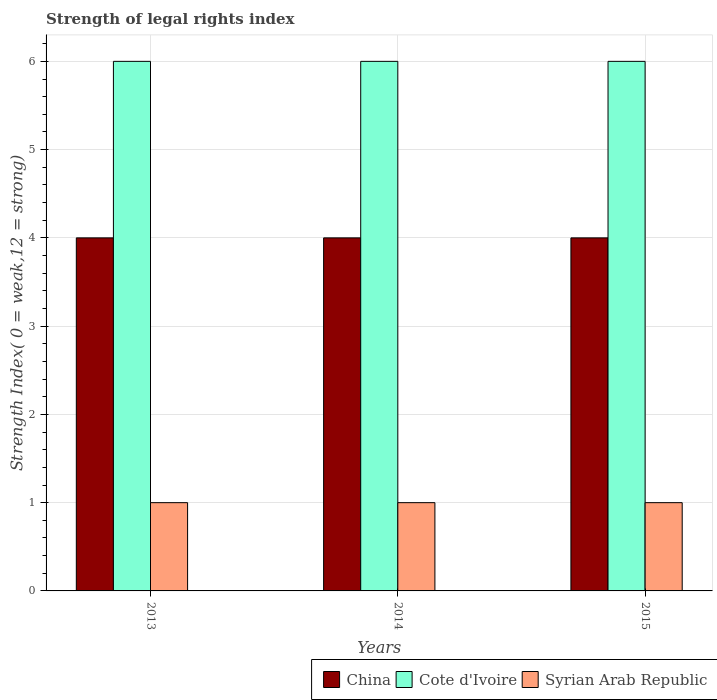How many groups of bars are there?
Your answer should be very brief. 3. Are the number of bars per tick equal to the number of legend labels?
Give a very brief answer. Yes. Are the number of bars on each tick of the X-axis equal?
Make the answer very short. Yes. How many bars are there on the 3rd tick from the right?
Your answer should be very brief. 3. What is the strength index in Syrian Arab Republic in 2014?
Provide a short and direct response. 1. Across all years, what is the maximum strength index in Cote d'Ivoire?
Your answer should be compact. 6. Across all years, what is the minimum strength index in China?
Your answer should be very brief. 4. In which year was the strength index in Syrian Arab Republic minimum?
Your answer should be very brief. 2013. What is the total strength index in Syrian Arab Republic in the graph?
Make the answer very short. 3. What is the difference between the strength index in Cote d'Ivoire in 2015 and the strength index in Syrian Arab Republic in 2013?
Give a very brief answer. 5. In the year 2013, what is the difference between the strength index in China and strength index in Syrian Arab Republic?
Make the answer very short. 3. In how many years, is the strength index in Cote d'Ivoire greater than 2?
Provide a short and direct response. 3. What is the ratio of the strength index in China in 2013 to that in 2014?
Your response must be concise. 1. Is the difference between the strength index in China in 2014 and 2015 greater than the difference between the strength index in Syrian Arab Republic in 2014 and 2015?
Your response must be concise. No. What is the difference between the highest and the second highest strength index in Cote d'Ivoire?
Provide a succinct answer. 0. In how many years, is the strength index in Cote d'Ivoire greater than the average strength index in Cote d'Ivoire taken over all years?
Offer a terse response. 0. What does the 2nd bar from the left in 2013 represents?
Offer a terse response. Cote d'Ivoire. What does the 2nd bar from the right in 2013 represents?
Your answer should be compact. Cote d'Ivoire. Is it the case that in every year, the sum of the strength index in Cote d'Ivoire and strength index in China is greater than the strength index in Syrian Arab Republic?
Your answer should be compact. Yes. How many bars are there?
Your answer should be compact. 9. How many years are there in the graph?
Provide a short and direct response. 3. Does the graph contain grids?
Make the answer very short. Yes. How many legend labels are there?
Keep it short and to the point. 3. What is the title of the graph?
Make the answer very short. Strength of legal rights index. What is the label or title of the Y-axis?
Your answer should be very brief. Strength Index( 0 = weak,12 = strong). What is the Strength Index( 0 = weak,12 = strong) in Cote d'Ivoire in 2013?
Give a very brief answer. 6. What is the Strength Index( 0 = weak,12 = strong) in Syrian Arab Republic in 2013?
Provide a short and direct response. 1. What is the Strength Index( 0 = weak,12 = strong) of China in 2015?
Provide a short and direct response. 4. What is the Strength Index( 0 = weak,12 = strong) of Cote d'Ivoire in 2015?
Provide a short and direct response. 6. Across all years, what is the maximum Strength Index( 0 = weak,12 = strong) in Syrian Arab Republic?
Your response must be concise. 1. Across all years, what is the minimum Strength Index( 0 = weak,12 = strong) in China?
Make the answer very short. 4. Across all years, what is the minimum Strength Index( 0 = weak,12 = strong) in Syrian Arab Republic?
Provide a short and direct response. 1. What is the total Strength Index( 0 = weak,12 = strong) of Cote d'Ivoire in the graph?
Provide a short and direct response. 18. What is the difference between the Strength Index( 0 = weak,12 = strong) in China in 2013 and that in 2014?
Make the answer very short. 0. What is the difference between the Strength Index( 0 = weak,12 = strong) of Cote d'Ivoire in 2013 and that in 2014?
Your response must be concise. 0. What is the difference between the Strength Index( 0 = weak,12 = strong) of Syrian Arab Republic in 2013 and that in 2014?
Ensure brevity in your answer.  0. What is the difference between the Strength Index( 0 = weak,12 = strong) of China in 2013 and that in 2015?
Your answer should be compact. 0. What is the difference between the Strength Index( 0 = weak,12 = strong) in Cote d'Ivoire in 2013 and that in 2015?
Your response must be concise. 0. What is the difference between the Strength Index( 0 = weak,12 = strong) in Syrian Arab Republic in 2013 and that in 2015?
Provide a succinct answer. 0. What is the difference between the Strength Index( 0 = weak,12 = strong) of Cote d'Ivoire in 2014 and that in 2015?
Your response must be concise. 0. What is the difference between the Strength Index( 0 = weak,12 = strong) in Syrian Arab Republic in 2014 and that in 2015?
Give a very brief answer. 0. What is the difference between the Strength Index( 0 = weak,12 = strong) of China in 2013 and the Strength Index( 0 = weak,12 = strong) of Cote d'Ivoire in 2014?
Give a very brief answer. -2. What is the difference between the Strength Index( 0 = weak,12 = strong) in China in 2013 and the Strength Index( 0 = weak,12 = strong) in Syrian Arab Republic in 2014?
Provide a short and direct response. 3. What is the difference between the Strength Index( 0 = weak,12 = strong) in China in 2013 and the Strength Index( 0 = weak,12 = strong) in Syrian Arab Republic in 2015?
Ensure brevity in your answer.  3. What is the difference between the Strength Index( 0 = weak,12 = strong) in China in 2014 and the Strength Index( 0 = weak,12 = strong) in Syrian Arab Republic in 2015?
Ensure brevity in your answer.  3. What is the average Strength Index( 0 = weak,12 = strong) in China per year?
Your response must be concise. 4. In the year 2013, what is the difference between the Strength Index( 0 = weak,12 = strong) in China and Strength Index( 0 = weak,12 = strong) in Syrian Arab Republic?
Provide a short and direct response. 3. In the year 2013, what is the difference between the Strength Index( 0 = weak,12 = strong) in Cote d'Ivoire and Strength Index( 0 = weak,12 = strong) in Syrian Arab Republic?
Provide a succinct answer. 5. In the year 2014, what is the difference between the Strength Index( 0 = weak,12 = strong) in China and Strength Index( 0 = weak,12 = strong) in Syrian Arab Republic?
Make the answer very short. 3. In the year 2014, what is the difference between the Strength Index( 0 = weak,12 = strong) in Cote d'Ivoire and Strength Index( 0 = weak,12 = strong) in Syrian Arab Republic?
Offer a very short reply. 5. In the year 2015, what is the difference between the Strength Index( 0 = weak,12 = strong) of China and Strength Index( 0 = weak,12 = strong) of Cote d'Ivoire?
Offer a terse response. -2. What is the ratio of the Strength Index( 0 = weak,12 = strong) of China in 2013 to that in 2014?
Offer a terse response. 1. What is the ratio of the Strength Index( 0 = weak,12 = strong) of Cote d'Ivoire in 2013 to that in 2014?
Ensure brevity in your answer.  1. What is the ratio of the Strength Index( 0 = weak,12 = strong) of Syrian Arab Republic in 2013 to that in 2014?
Offer a very short reply. 1. What is the ratio of the Strength Index( 0 = weak,12 = strong) in China in 2013 to that in 2015?
Provide a succinct answer. 1. What is the ratio of the Strength Index( 0 = weak,12 = strong) of Syrian Arab Republic in 2014 to that in 2015?
Give a very brief answer. 1. What is the difference between the highest and the lowest Strength Index( 0 = weak,12 = strong) in China?
Provide a succinct answer. 0. What is the difference between the highest and the lowest Strength Index( 0 = weak,12 = strong) of Cote d'Ivoire?
Keep it short and to the point. 0. What is the difference between the highest and the lowest Strength Index( 0 = weak,12 = strong) of Syrian Arab Republic?
Your answer should be compact. 0. 